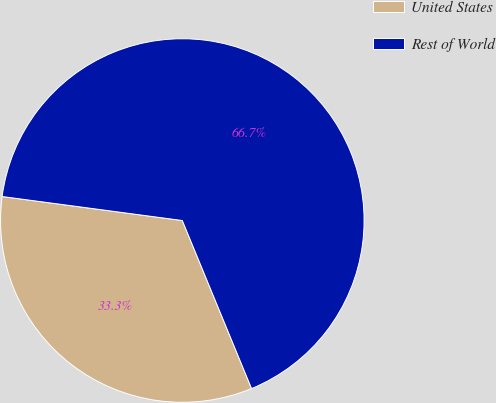Convert chart. <chart><loc_0><loc_0><loc_500><loc_500><pie_chart><fcel>United States<fcel>Rest of World<nl><fcel>33.33%<fcel>66.67%<nl></chart> 